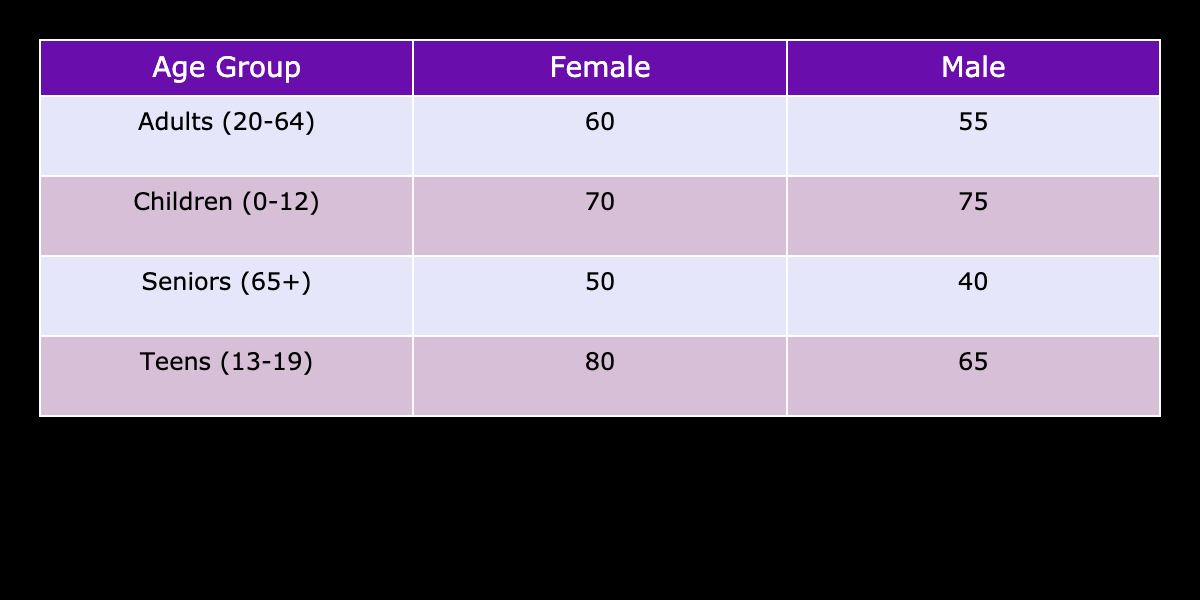What is the participation rate for females in the Teens (13-19) age group? The table shows a participation rate of 80% for females in the Teens (13-19) age group. This value is directly retrievable from the table under the corresponding row and column.
Answer: 80 What is the participation rate for males in the Seniors (65+) age group? According to the table, the participation rate for males in the Seniors (65+) age group is 40%. This is found directly in the respective row and column.
Answer: 40 Which age group has the highest participation rate for males? By inspecting the table, the highest participation rate for males is 75% in the Children (0-12) age group. This is assessed by comparing all the male participation rates listed.
Answer: Children (0-12) What is the difference in participation rates between females and males in the Adults (20-64) age group? For females, the participation rate is 60% and for males, it is 55%. The difference is calculated as 60 - 55 = 5%. This requires finding the values in the corresponding row and subtracting them.
Answer: 5 Is the participation rate for females in the Adults (20-64) age group higher than that for males? By comparing the rates from the table, females have a participation rate of 60% while males have 55%. Since 60% is greater than 55%, the answer is yes.
Answer: Yes What is the average participation rate for all age groups for males? To find the average, we take the participation rates for males (75, 65, 55, and 40), sum them to get 75 + 65 + 55 + 40 = 235, and divide by the number of groups, which is 4. Thus, the average is 235 / 4 = 58.75%.
Answer: 58.75 Which gender has a higher participation rate overall when combining all age groups? We add the participation rates for each gender across all age groups: Males (75 + 65 + 55 + 40 = 235) and Females (70 + 80 + 60 + 50 = 260). Comparing the totals, females have a higher combined participation rate, with 260 > 235.
Answer: Females In which age group do both genders have participation rates below 50%? Referring to the table, the only age group where both genders have participation rates below 50% is the Seniors (65+), where males have 40% and females have 50%. This comparison shows that females are just at 50%, not below.
Answer: None 